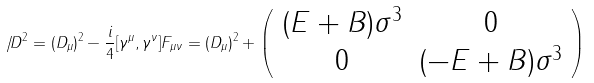<formula> <loc_0><loc_0><loc_500><loc_500>{ \not \, D } ^ { 2 } = ( D _ { \mu } ) ^ { 2 } - \frac { i } { 4 } [ \gamma ^ { \mu } , \gamma ^ { \nu } ] F _ { \mu \nu } = ( D _ { \mu } ) ^ { 2 } + \left ( \begin{array} { c c } ( E + B ) \sigma ^ { 3 } & 0 \\ 0 & ( - E + B ) \sigma ^ { 3 } \end{array} \right )</formula> 